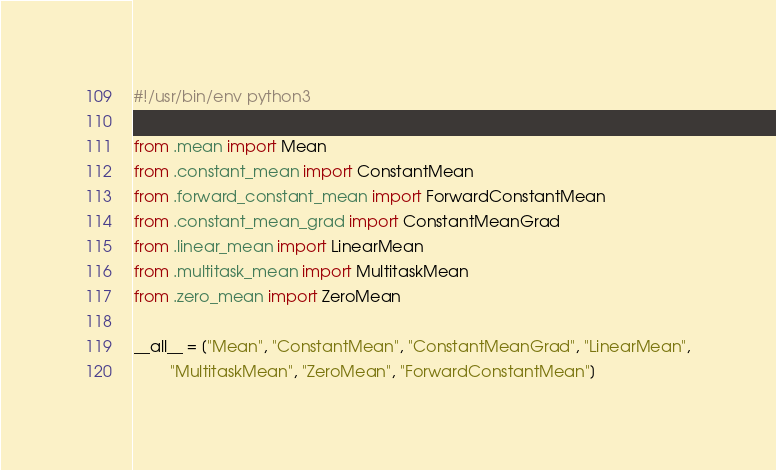<code> <loc_0><loc_0><loc_500><loc_500><_Python_>#!/usr/bin/env python3

from .mean import Mean
from .constant_mean import ConstantMean
from .forward_constant_mean import ForwardConstantMean
from .constant_mean_grad import ConstantMeanGrad
from .linear_mean import LinearMean
from .multitask_mean import MultitaskMean
from .zero_mean import ZeroMean

__all__ = ["Mean", "ConstantMean", "ConstantMeanGrad", "LinearMean",
        "MultitaskMean", "ZeroMean", "ForwardConstantMean"]
</code> 